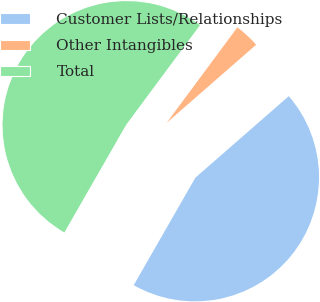<chart> <loc_0><loc_0><loc_500><loc_500><pie_chart><fcel>Customer Lists/Relationships<fcel>Other Intangibles<fcel>Total<nl><fcel>44.71%<fcel>3.43%<fcel>51.86%<nl></chart> 